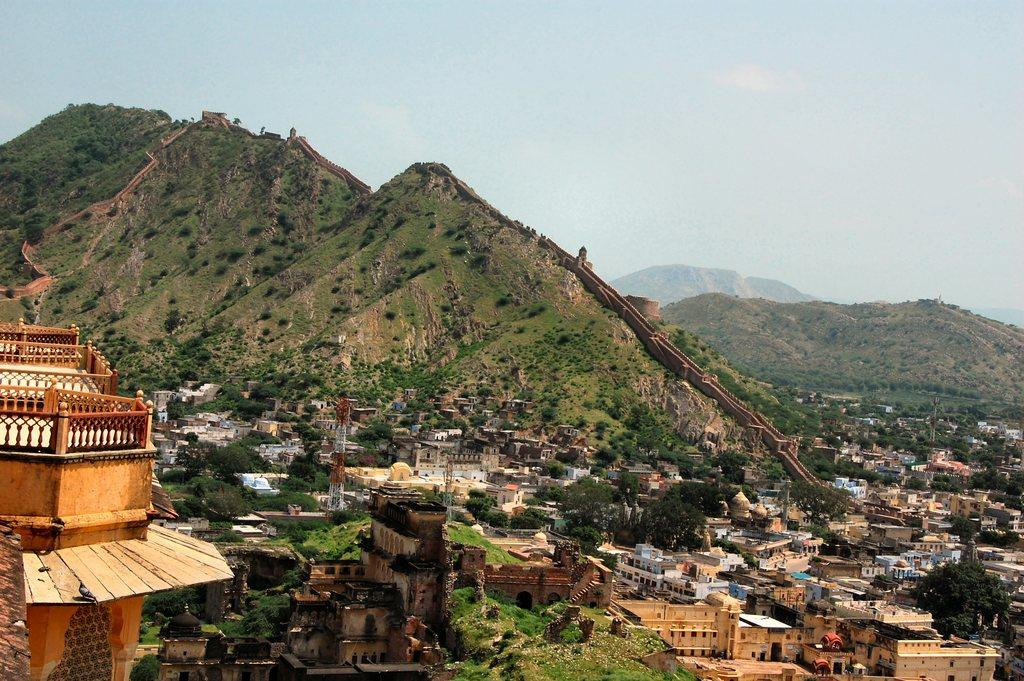What type of structures can be seen in the image? There are buildings in the image. What natural elements are present in the image? There are trees, mountains, and grass in the image. What else can be seen in the image besides buildings and natural elements? There are objects in the image. What is visible in the background of the image? The sky is visible in the background of the image. What reason does the actor have for being in the image? There is no actor present in the image; it features buildings, trees, mountains, grass, objects, and the sky. Can you see an airplane flying in the image? There is no airplane visible in the image. 